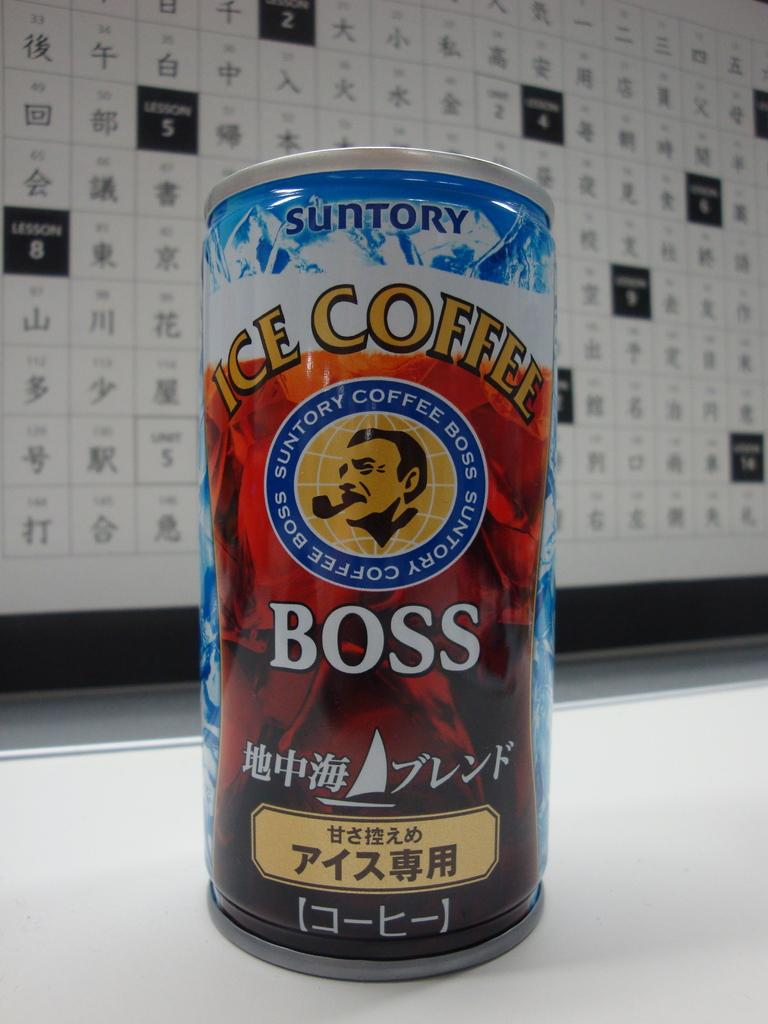<image>
Share a concise interpretation of the image provided. A can of Suntory Ice Coffee with foreign characters on the can. 